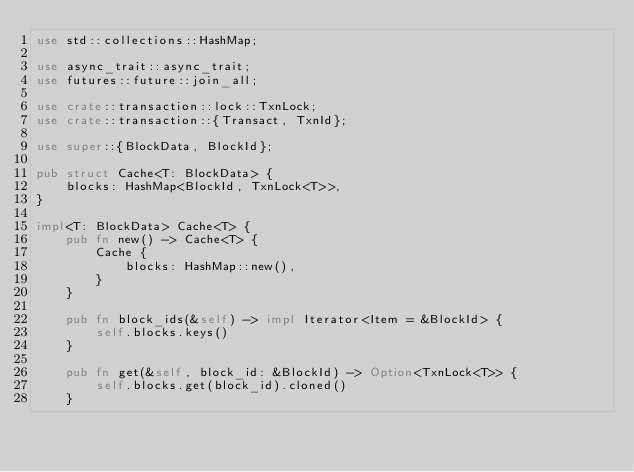<code> <loc_0><loc_0><loc_500><loc_500><_Rust_>use std::collections::HashMap;

use async_trait::async_trait;
use futures::future::join_all;

use crate::transaction::lock::TxnLock;
use crate::transaction::{Transact, TxnId};

use super::{BlockData, BlockId};

pub struct Cache<T: BlockData> {
    blocks: HashMap<BlockId, TxnLock<T>>,
}

impl<T: BlockData> Cache<T> {
    pub fn new() -> Cache<T> {
        Cache {
            blocks: HashMap::new(),
        }
    }

    pub fn block_ids(&self) -> impl Iterator<Item = &BlockId> {
        self.blocks.keys()
    }

    pub fn get(&self, block_id: &BlockId) -> Option<TxnLock<T>> {
        self.blocks.get(block_id).cloned()
    }
</code> 